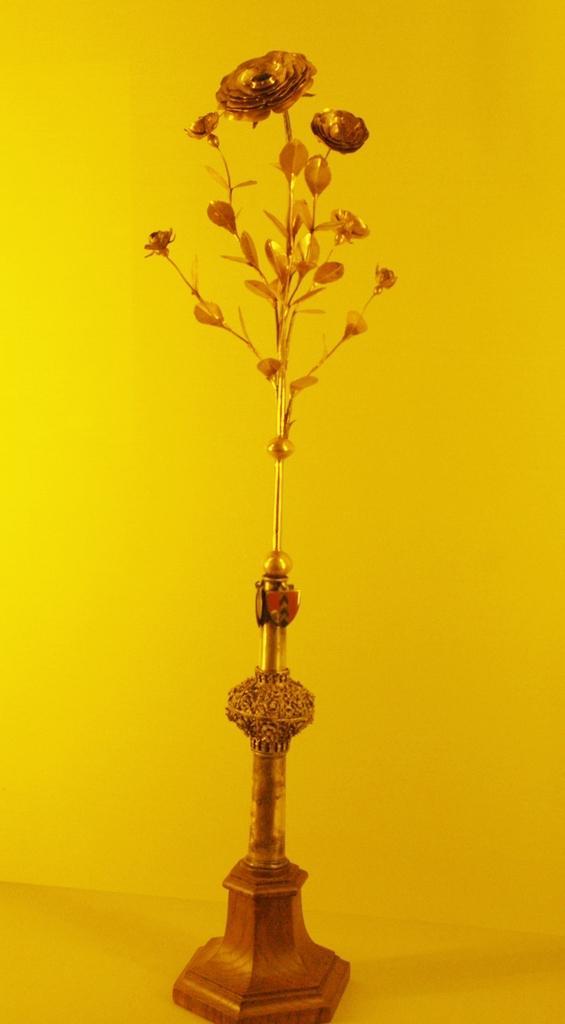Describe this image in one or two sentences. In the center of the image there is a flower vase on the surface and the background is in plain yellow color. 